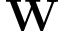Convert formula to latex. <formula><loc_0><loc_0><loc_500><loc_500>W</formula> 